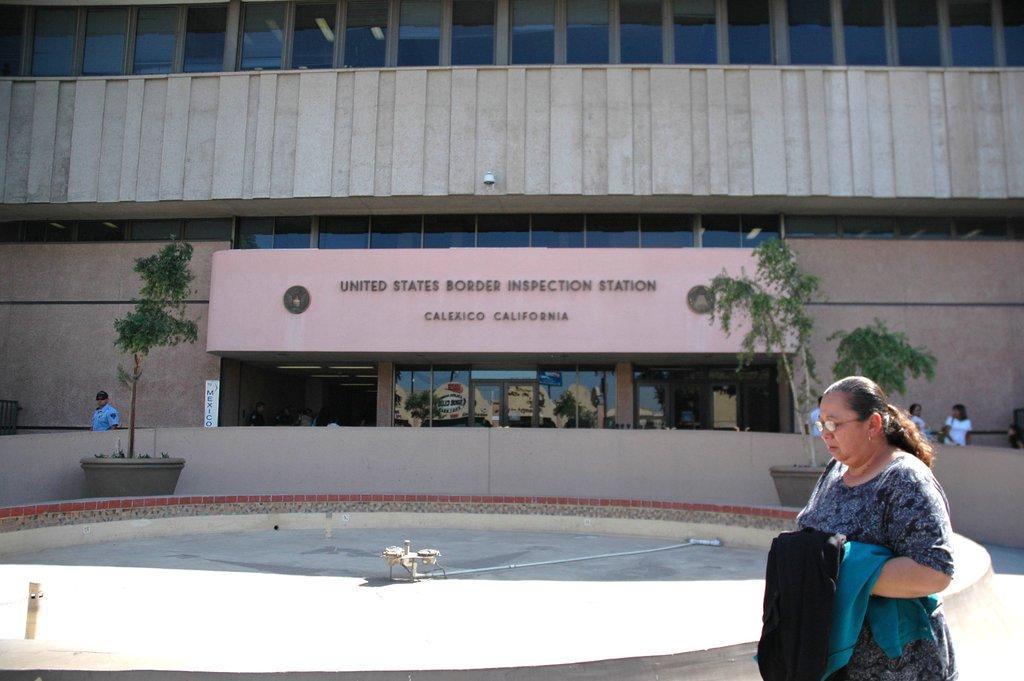How would you summarize this image in a sentence or two? In the front of the image I can see a woman and a water fountain without water. In the background of the image there is a building, people, plants, boards and glass windows. On these glass windows there is a reflection of trees, building and sky. Through these glass windows I can able to see lights. 